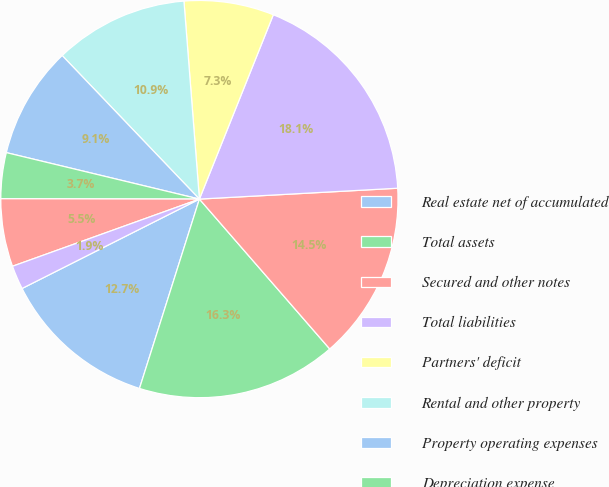Convert chart. <chart><loc_0><loc_0><loc_500><loc_500><pie_chart><fcel>Real estate net of accumulated<fcel>Total assets<fcel>Secured and other notes<fcel>Total liabilities<fcel>Partners' deficit<fcel>Rental and other property<fcel>Property operating expenses<fcel>Depreciation expense<fcel>Interest expense<fcel>Gain on sale<nl><fcel>12.69%<fcel>16.27%<fcel>14.48%<fcel>18.06%<fcel>7.31%<fcel>10.9%<fcel>9.1%<fcel>3.73%<fcel>5.52%<fcel>1.94%<nl></chart> 